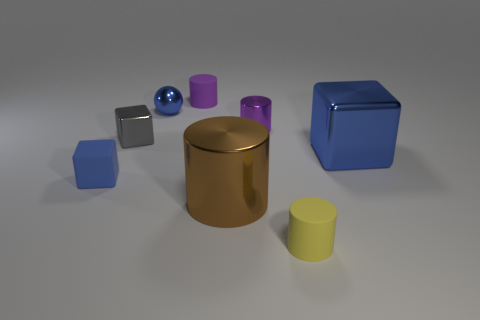Add 2 cyan matte things. How many objects exist? 10 Subtract all spheres. How many objects are left? 7 Subtract all small gray metal cubes. Subtract all big brown metallic cylinders. How many objects are left? 6 Add 2 gray metallic cubes. How many gray metallic cubes are left? 3 Add 3 tiny yellow objects. How many tiny yellow objects exist? 4 Subtract 0 gray balls. How many objects are left? 8 